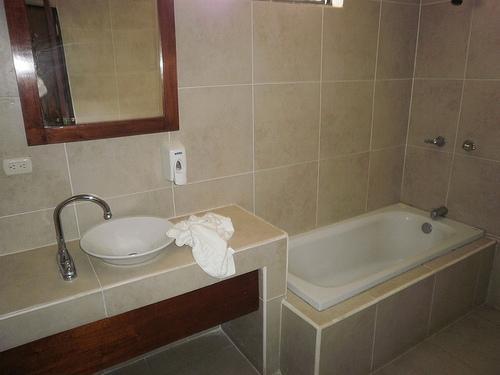How many sinks are in the picture?
Give a very brief answer. 1. How many mirrors are on the wall?
Give a very brief answer. 1. How many bathtubs are there?
Give a very brief answer. 1. 